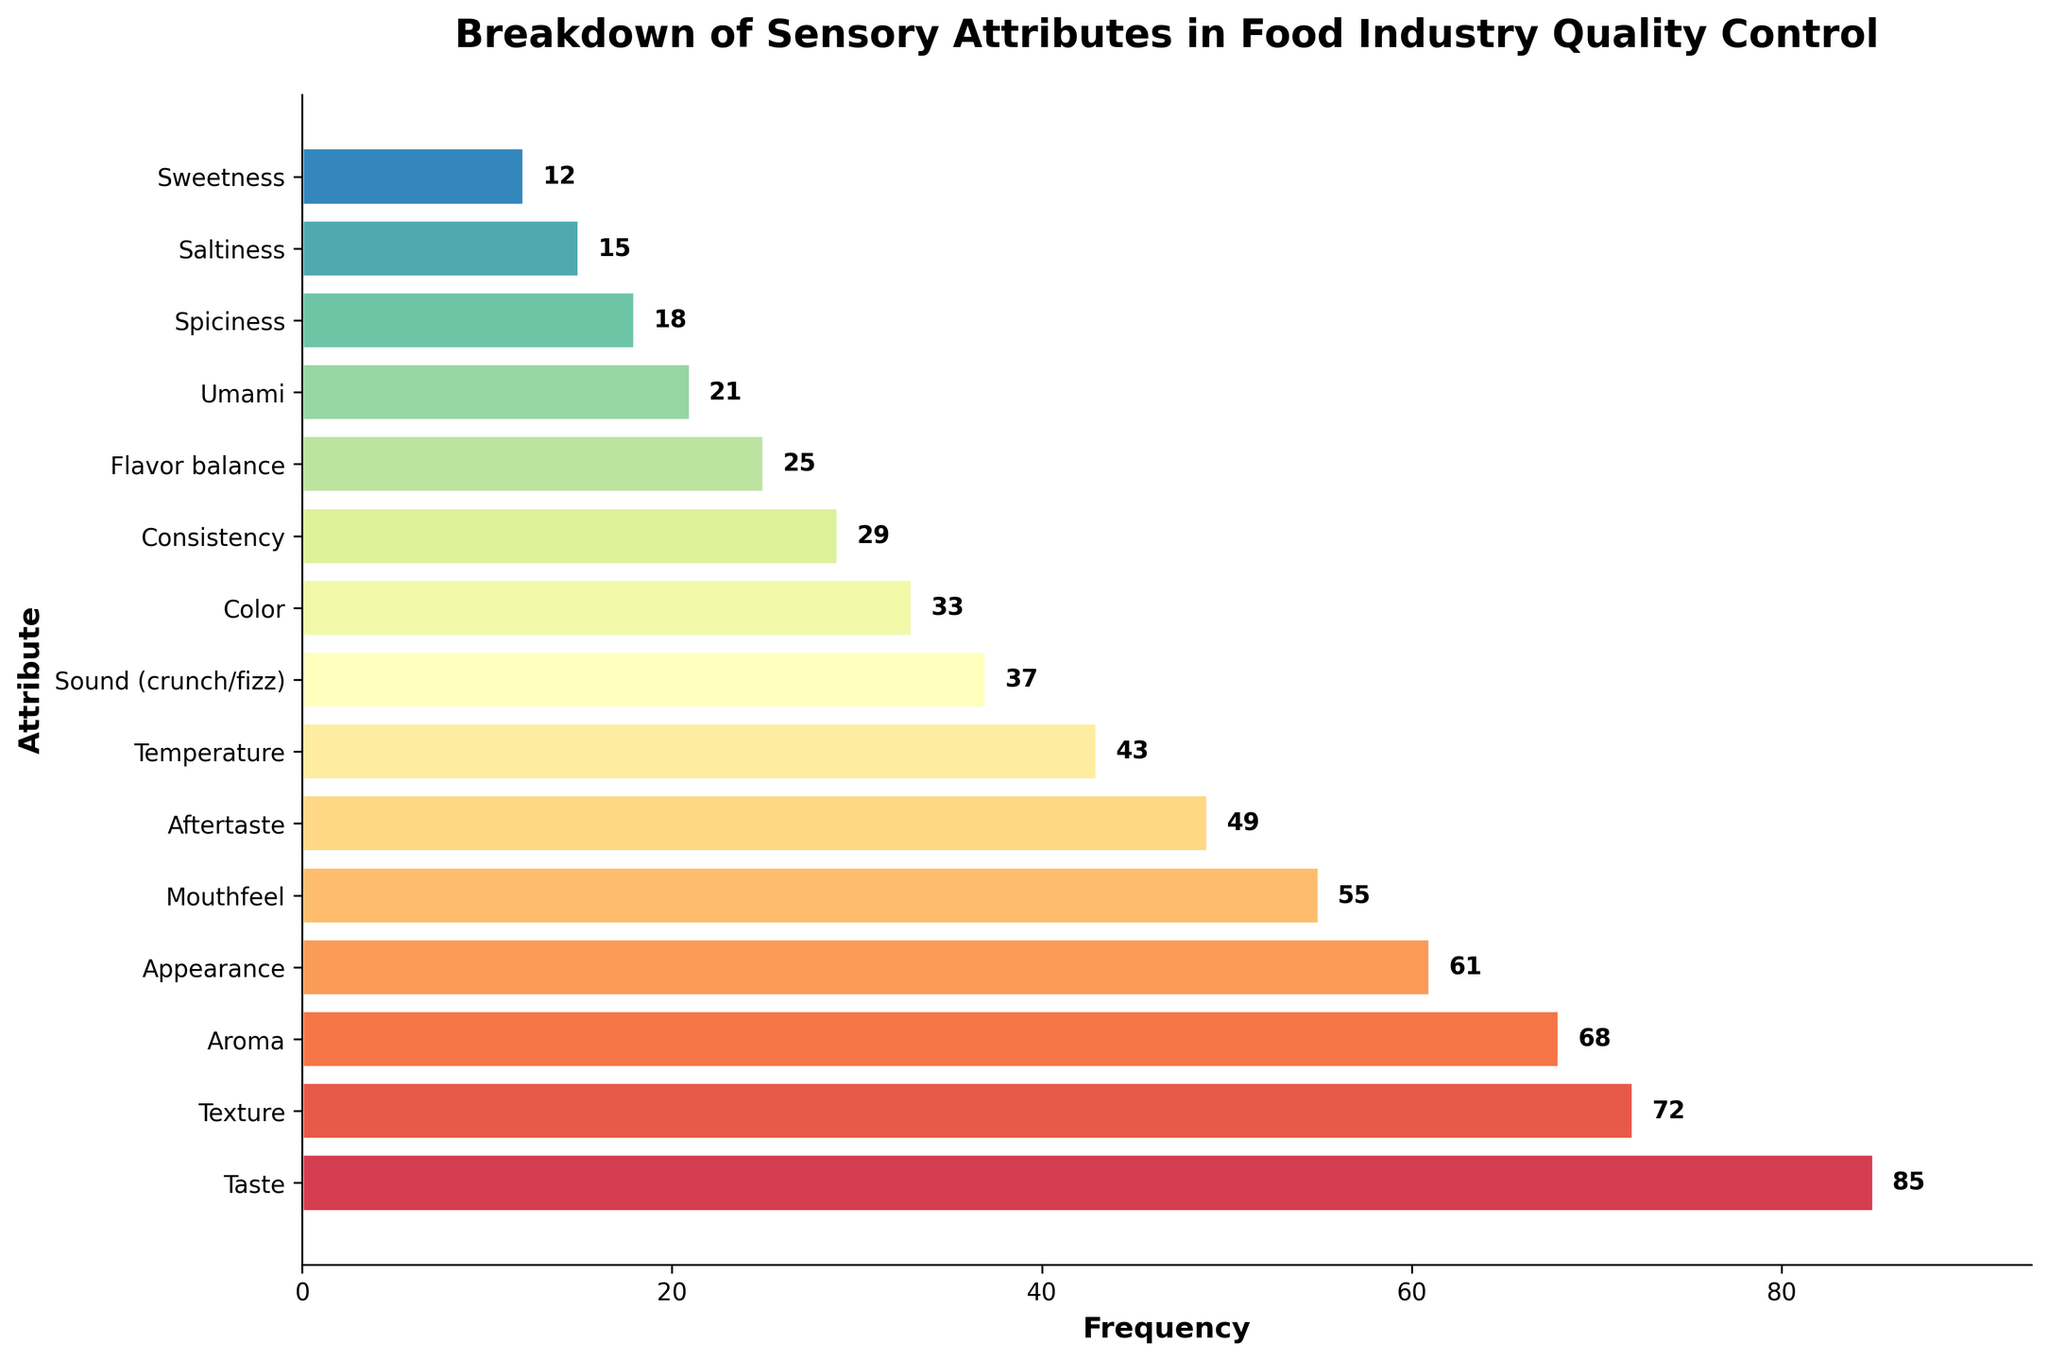What's the most frequently tested sensory attribute in the food industry? Look at the attribute with the tallest bar in the horizontal bar chart. The label associated with this bar shows the highest frequency.
Answer: Taste Which sensory attribute is tested the least frequently? Find the attribute with the shortest bar in the horizontal bar chart. The label associated with this bar shows the lowest frequency.
Answer: Sweetness What is the combined frequency of the top three sensory attributes? Identify the frequencies of the top three attributes: Taste (85), Texture (72), and Aroma (68). Sum these values: 85 + 72 + 68 = 225.
Answer: 225 How much more frequently is 'Taste' tested compared to 'Umami'? Look at the frequencies for Taste (85) and Umami (21) and find the difference: 85 - 21 = 64.
Answer: 64 Is Temperature tested more frequently than Sound (crunch/fizz)? Compare the frequencies of Temperature (43) and Sound (crunch/fizz) (37). Since 43 > 37, Temperature is tested more frequently.
Answer: Yes Which attribute has a frequency closest to 50? Identify the attribute frequency values close to 50. 'Aftertaste' has a frequency of 49, which is closest to 50.
Answer: Aftertaste What is the average frequency of 'Color', 'Consistency', and 'Flavor balance'? Sum the frequencies: Color (33), Consistency (29), and Flavor balance (25): 33 + 29 + 25 = 87. Then divide by the number of attributes, 87/3 = 29.
Answer: 29 Which attribute's bar is visually in the middle in terms of frequency? Visually scan the chart for the attribute whose bar is in the middle. 'Mouthfeel' with a frequency of 55 appears in the middle.
Answer: Mouthfeel Are there more attributes with a frequency higher than 50 or lower than 50? Count the attributes with frequencies above 50: Taste, Texture, Aroma, Appearance, and Mouthfeel (5). Count the attributes with frequencies below 50: Aftertaste, Temperature, Sound (crunch/fizz), Color, Consistency, Flavor balance, Umami, Spiciness, Saltiness, Sweetness (10).
Answer: Lower than 50 What is the frequency difference between 'Aroma' and 'Appearance'? Look at the frequencies for Aroma (68) and Appearance (61) and find the difference: 68 - 61 = 7.
Answer: 7 